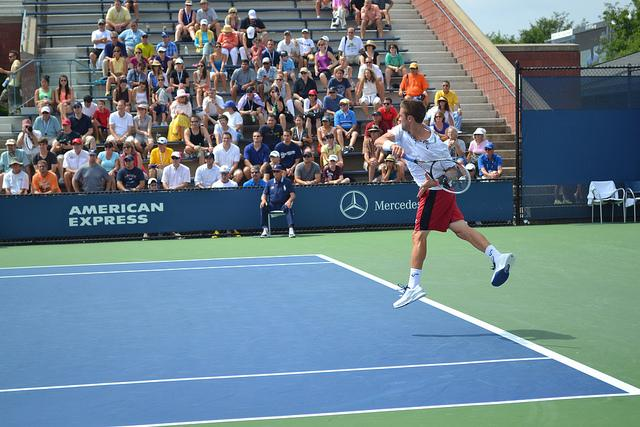Which company has sponsored this event? american express 